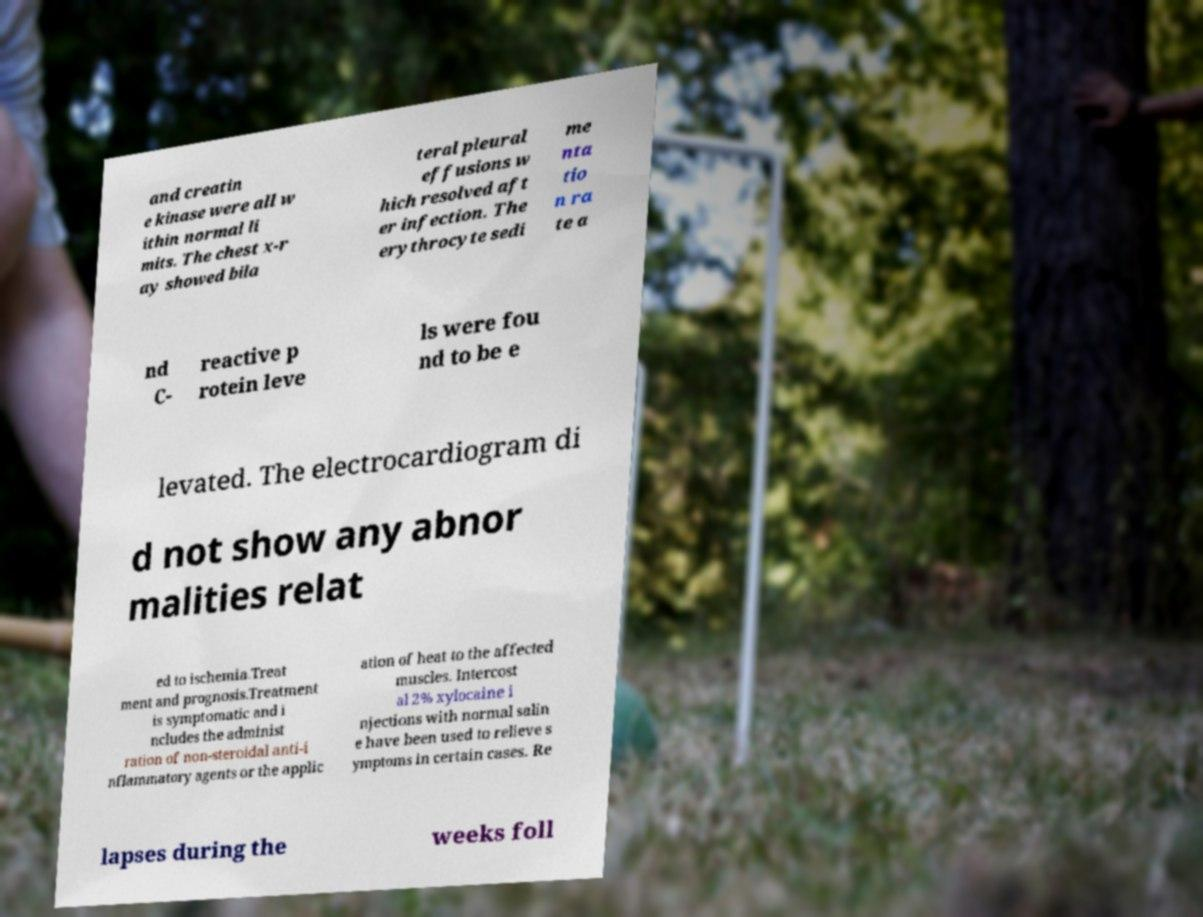There's text embedded in this image that I need extracted. Can you transcribe it verbatim? and creatin e kinase were all w ithin normal li mits. The chest x-r ay showed bila teral pleural effusions w hich resolved aft er infection. The erythrocyte sedi me nta tio n ra te a nd C- reactive p rotein leve ls were fou nd to be e levated. The electrocardiogram di d not show any abnor malities relat ed to ischemia.Treat ment and prognosis.Treatment is symptomatic and i ncludes the administ ration of non-steroidal anti-i nflammatory agents or the applic ation of heat to the affected muscles. Intercost al 2% xylocaine i njections with normal salin e have been used to relieve s ymptoms in certain cases. Re lapses during the weeks foll 